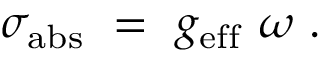Convert formula to latex. <formula><loc_0><loc_0><loc_500><loc_500>\sigma _ { a b s } = g _ { e f f } \omega .</formula> 